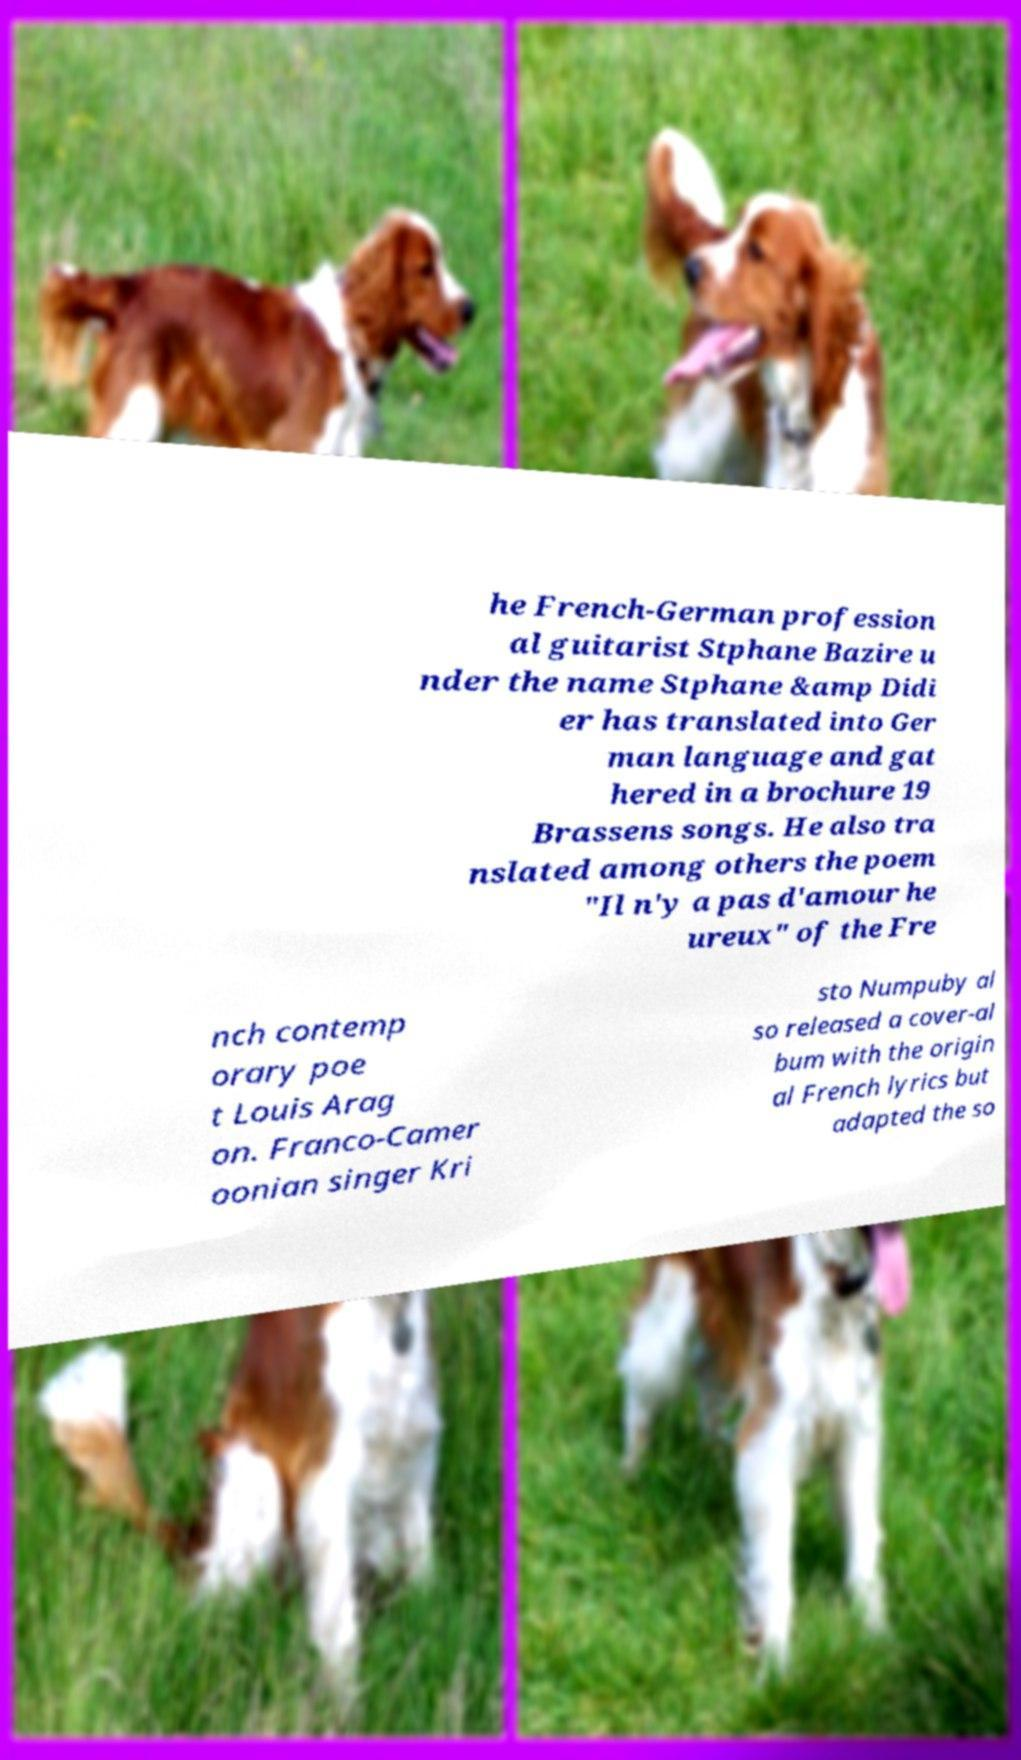Could you assist in decoding the text presented in this image and type it out clearly? he French-German profession al guitarist Stphane Bazire u nder the name Stphane &amp Didi er has translated into Ger man language and gat hered in a brochure 19 Brassens songs. He also tra nslated among others the poem "Il n'y a pas d'amour he ureux" of the Fre nch contemp orary poe t Louis Arag on. Franco-Camer oonian singer Kri sto Numpuby al so released a cover-al bum with the origin al French lyrics but adapted the so 